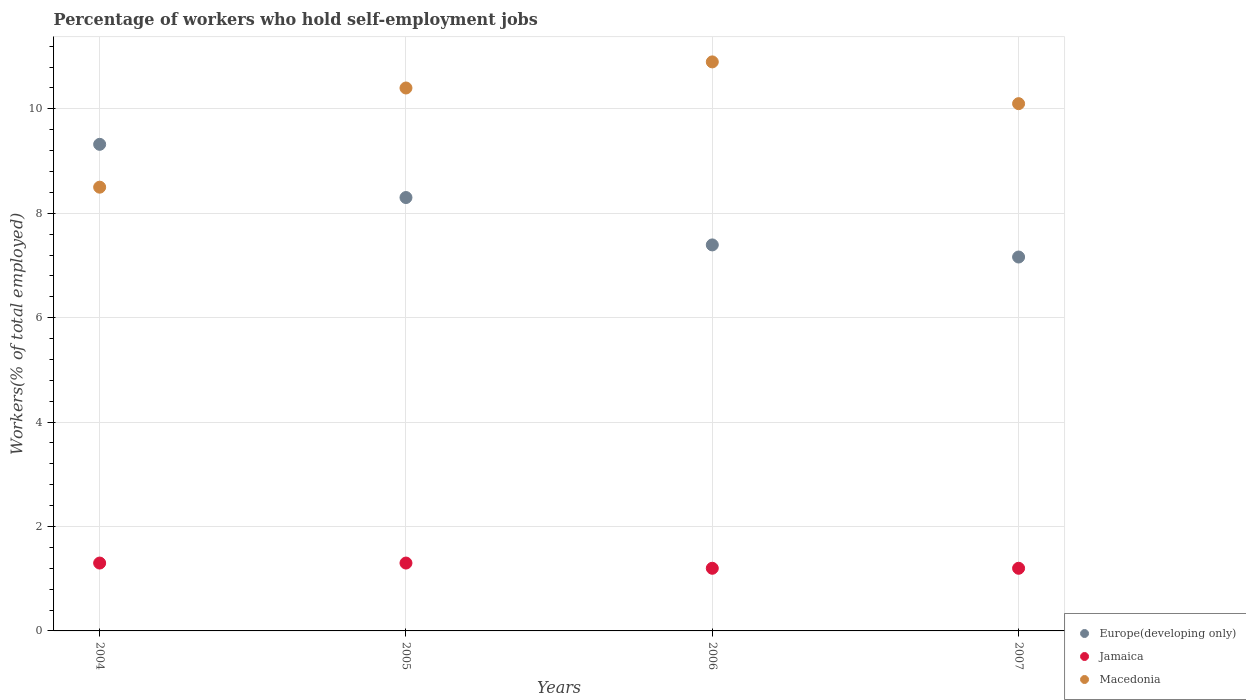What is the percentage of self-employed workers in Jamaica in 2005?
Keep it short and to the point. 1.3. Across all years, what is the maximum percentage of self-employed workers in Europe(developing only)?
Ensure brevity in your answer.  9.32. Across all years, what is the minimum percentage of self-employed workers in Macedonia?
Keep it short and to the point. 8.5. In which year was the percentage of self-employed workers in Europe(developing only) maximum?
Give a very brief answer. 2004. In which year was the percentage of self-employed workers in Europe(developing only) minimum?
Your answer should be very brief. 2007. What is the total percentage of self-employed workers in Macedonia in the graph?
Offer a terse response. 39.9. What is the difference between the percentage of self-employed workers in Jamaica in 2006 and that in 2007?
Keep it short and to the point. 0. What is the difference between the percentage of self-employed workers in Macedonia in 2006 and the percentage of self-employed workers in Jamaica in 2004?
Keep it short and to the point. 9.6. What is the average percentage of self-employed workers in Macedonia per year?
Your response must be concise. 9.97. In the year 2007, what is the difference between the percentage of self-employed workers in Europe(developing only) and percentage of self-employed workers in Jamaica?
Give a very brief answer. 5.96. In how many years, is the percentage of self-employed workers in Jamaica greater than 5.6 %?
Give a very brief answer. 0. What is the ratio of the percentage of self-employed workers in Jamaica in 2004 to that in 2007?
Your answer should be very brief. 1.08. Is the percentage of self-employed workers in Europe(developing only) in 2004 less than that in 2006?
Provide a short and direct response. No. Is the difference between the percentage of self-employed workers in Europe(developing only) in 2004 and 2007 greater than the difference between the percentage of self-employed workers in Jamaica in 2004 and 2007?
Keep it short and to the point. Yes. What is the difference between the highest and the lowest percentage of self-employed workers in Jamaica?
Provide a succinct answer. 0.1. In how many years, is the percentage of self-employed workers in Macedonia greater than the average percentage of self-employed workers in Macedonia taken over all years?
Offer a terse response. 3. Is the percentage of self-employed workers in Europe(developing only) strictly greater than the percentage of self-employed workers in Macedonia over the years?
Provide a succinct answer. No. What is the difference between two consecutive major ticks on the Y-axis?
Ensure brevity in your answer.  2. Does the graph contain grids?
Ensure brevity in your answer.  Yes. How many legend labels are there?
Offer a terse response. 3. What is the title of the graph?
Make the answer very short. Percentage of workers who hold self-employment jobs. What is the label or title of the X-axis?
Provide a short and direct response. Years. What is the label or title of the Y-axis?
Your answer should be very brief. Workers(% of total employed). What is the Workers(% of total employed) in Europe(developing only) in 2004?
Give a very brief answer. 9.32. What is the Workers(% of total employed) of Jamaica in 2004?
Offer a terse response. 1.3. What is the Workers(% of total employed) in Europe(developing only) in 2005?
Ensure brevity in your answer.  8.3. What is the Workers(% of total employed) in Jamaica in 2005?
Make the answer very short. 1.3. What is the Workers(% of total employed) in Macedonia in 2005?
Your answer should be very brief. 10.4. What is the Workers(% of total employed) in Europe(developing only) in 2006?
Your answer should be very brief. 7.39. What is the Workers(% of total employed) in Jamaica in 2006?
Your response must be concise. 1.2. What is the Workers(% of total employed) of Macedonia in 2006?
Offer a very short reply. 10.9. What is the Workers(% of total employed) of Europe(developing only) in 2007?
Ensure brevity in your answer.  7.16. What is the Workers(% of total employed) of Jamaica in 2007?
Make the answer very short. 1.2. What is the Workers(% of total employed) in Macedonia in 2007?
Your answer should be very brief. 10.1. Across all years, what is the maximum Workers(% of total employed) in Europe(developing only)?
Your response must be concise. 9.32. Across all years, what is the maximum Workers(% of total employed) of Jamaica?
Make the answer very short. 1.3. Across all years, what is the maximum Workers(% of total employed) of Macedonia?
Your answer should be very brief. 10.9. Across all years, what is the minimum Workers(% of total employed) in Europe(developing only)?
Your answer should be very brief. 7.16. Across all years, what is the minimum Workers(% of total employed) in Jamaica?
Ensure brevity in your answer.  1.2. What is the total Workers(% of total employed) in Europe(developing only) in the graph?
Offer a very short reply. 32.18. What is the total Workers(% of total employed) in Macedonia in the graph?
Ensure brevity in your answer.  39.9. What is the difference between the Workers(% of total employed) in Europe(developing only) in 2004 and that in 2005?
Your answer should be compact. 1.02. What is the difference between the Workers(% of total employed) in Jamaica in 2004 and that in 2005?
Keep it short and to the point. 0. What is the difference between the Workers(% of total employed) in Macedonia in 2004 and that in 2005?
Keep it short and to the point. -1.9. What is the difference between the Workers(% of total employed) of Europe(developing only) in 2004 and that in 2006?
Keep it short and to the point. 1.93. What is the difference between the Workers(% of total employed) in Macedonia in 2004 and that in 2006?
Offer a very short reply. -2.4. What is the difference between the Workers(% of total employed) of Europe(developing only) in 2004 and that in 2007?
Provide a succinct answer. 2.16. What is the difference between the Workers(% of total employed) in Jamaica in 2004 and that in 2007?
Your response must be concise. 0.1. What is the difference between the Workers(% of total employed) in Europe(developing only) in 2005 and that in 2006?
Offer a terse response. 0.91. What is the difference between the Workers(% of total employed) of Europe(developing only) in 2005 and that in 2007?
Offer a terse response. 1.14. What is the difference between the Workers(% of total employed) in Europe(developing only) in 2006 and that in 2007?
Your response must be concise. 0.23. What is the difference between the Workers(% of total employed) in Macedonia in 2006 and that in 2007?
Your answer should be very brief. 0.8. What is the difference between the Workers(% of total employed) in Europe(developing only) in 2004 and the Workers(% of total employed) in Jamaica in 2005?
Offer a terse response. 8.02. What is the difference between the Workers(% of total employed) of Europe(developing only) in 2004 and the Workers(% of total employed) of Macedonia in 2005?
Your response must be concise. -1.08. What is the difference between the Workers(% of total employed) of Europe(developing only) in 2004 and the Workers(% of total employed) of Jamaica in 2006?
Your response must be concise. 8.12. What is the difference between the Workers(% of total employed) of Europe(developing only) in 2004 and the Workers(% of total employed) of Macedonia in 2006?
Make the answer very short. -1.58. What is the difference between the Workers(% of total employed) of Jamaica in 2004 and the Workers(% of total employed) of Macedonia in 2006?
Provide a succinct answer. -9.6. What is the difference between the Workers(% of total employed) in Europe(developing only) in 2004 and the Workers(% of total employed) in Jamaica in 2007?
Ensure brevity in your answer.  8.12. What is the difference between the Workers(% of total employed) of Europe(developing only) in 2004 and the Workers(% of total employed) of Macedonia in 2007?
Keep it short and to the point. -0.78. What is the difference between the Workers(% of total employed) in Jamaica in 2004 and the Workers(% of total employed) in Macedonia in 2007?
Your answer should be very brief. -8.8. What is the difference between the Workers(% of total employed) in Europe(developing only) in 2005 and the Workers(% of total employed) in Jamaica in 2006?
Your answer should be very brief. 7.1. What is the difference between the Workers(% of total employed) in Europe(developing only) in 2005 and the Workers(% of total employed) in Macedonia in 2006?
Provide a succinct answer. -2.6. What is the difference between the Workers(% of total employed) of Jamaica in 2005 and the Workers(% of total employed) of Macedonia in 2006?
Make the answer very short. -9.6. What is the difference between the Workers(% of total employed) of Europe(developing only) in 2005 and the Workers(% of total employed) of Jamaica in 2007?
Provide a succinct answer. 7.1. What is the difference between the Workers(% of total employed) in Europe(developing only) in 2005 and the Workers(% of total employed) in Macedonia in 2007?
Offer a terse response. -1.8. What is the difference between the Workers(% of total employed) in Jamaica in 2005 and the Workers(% of total employed) in Macedonia in 2007?
Keep it short and to the point. -8.8. What is the difference between the Workers(% of total employed) in Europe(developing only) in 2006 and the Workers(% of total employed) in Jamaica in 2007?
Your answer should be very brief. 6.19. What is the difference between the Workers(% of total employed) in Europe(developing only) in 2006 and the Workers(% of total employed) in Macedonia in 2007?
Provide a succinct answer. -2.71. What is the average Workers(% of total employed) in Europe(developing only) per year?
Provide a succinct answer. 8.04. What is the average Workers(% of total employed) of Jamaica per year?
Keep it short and to the point. 1.25. What is the average Workers(% of total employed) in Macedonia per year?
Ensure brevity in your answer.  9.97. In the year 2004, what is the difference between the Workers(% of total employed) of Europe(developing only) and Workers(% of total employed) of Jamaica?
Your answer should be very brief. 8.02. In the year 2004, what is the difference between the Workers(% of total employed) of Europe(developing only) and Workers(% of total employed) of Macedonia?
Your answer should be compact. 0.82. In the year 2004, what is the difference between the Workers(% of total employed) of Jamaica and Workers(% of total employed) of Macedonia?
Ensure brevity in your answer.  -7.2. In the year 2005, what is the difference between the Workers(% of total employed) of Europe(developing only) and Workers(% of total employed) of Jamaica?
Ensure brevity in your answer.  7. In the year 2005, what is the difference between the Workers(% of total employed) of Europe(developing only) and Workers(% of total employed) of Macedonia?
Your answer should be very brief. -2.1. In the year 2006, what is the difference between the Workers(% of total employed) of Europe(developing only) and Workers(% of total employed) of Jamaica?
Your answer should be compact. 6.19. In the year 2006, what is the difference between the Workers(% of total employed) in Europe(developing only) and Workers(% of total employed) in Macedonia?
Offer a very short reply. -3.51. In the year 2006, what is the difference between the Workers(% of total employed) in Jamaica and Workers(% of total employed) in Macedonia?
Offer a terse response. -9.7. In the year 2007, what is the difference between the Workers(% of total employed) in Europe(developing only) and Workers(% of total employed) in Jamaica?
Your answer should be compact. 5.96. In the year 2007, what is the difference between the Workers(% of total employed) of Europe(developing only) and Workers(% of total employed) of Macedonia?
Offer a very short reply. -2.94. What is the ratio of the Workers(% of total employed) of Europe(developing only) in 2004 to that in 2005?
Make the answer very short. 1.12. What is the ratio of the Workers(% of total employed) of Macedonia in 2004 to that in 2005?
Your answer should be very brief. 0.82. What is the ratio of the Workers(% of total employed) of Europe(developing only) in 2004 to that in 2006?
Your answer should be very brief. 1.26. What is the ratio of the Workers(% of total employed) of Macedonia in 2004 to that in 2006?
Keep it short and to the point. 0.78. What is the ratio of the Workers(% of total employed) of Europe(developing only) in 2004 to that in 2007?
Your response must be concise. 1.3. What is the ratio of the Workers(% of total employed) in Jamaica in 2004 to that in 2007?
Offer a very short reply. 1.08. What is the ratio of the Workers(% of total employed) of Macedonia in 2004 to that in 2007?
Keep it short and to the point. 0.84. What is the ratio of the Workers(% of total employed) in Europe(developing only) in 2005 to that in 2006?
Offer a very short reply. 1.12. What is the ratio of the Workers(% of total employed) in Jamaica in 2005 to that in 2006?
Provide a succinct answer. 1.08. What is the ratio of the Workers(% of total employed) of Macedonia in 2005 to that in 2006?
Provide a succinct answer. 0.95. What is the ratio of the Workers(% of total employed) in Europe(developing only) in 2005 to that in 2007?
Offer a very short reply. 1.16. What is the ratio of the Workers(% of total employed) in Jamaica in 2005 to that in 2007?
Your answer should be compact. 1.08. What is the ratio of the Workers(% of total employed) in Macedonia in 2005 to that in 2007?
Keep it short and to the point. 1.03. What is the ratio of the Workers(% of total employed) of Europe(developing only) in 2006 to that in 2007?
Your answer should be very brief. 1.03. What is the ratio of the Workers(% of total employed) in Macedonia in 2006 to that in 2007?
Your answer should be compact. 1.08. What is the difference between the highest and the second highest Workers(% of total employed) of Europe(developing only)?
Provide a short and direct response. 1.02. What is the difference between the highest and the second highest Workers(% of total employed) of Jamaica?
Offer a very short reply. 0. What is the difference between the highest and the second highest Workers(% of total employed) of Macedonia?
Keep it short and to the point. 0.5. What is the difference between the highest and the lowest Workers(% of total employed) of Europe(developing only)?
Give a very brief answer. 2.16. 